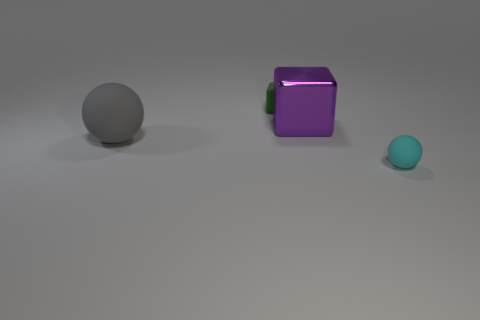Subtract 1 spheres. How many spheres are left? 1 Add 4 big metallic objects. How many big metallic objects are left? 5 Add 4 small purple matte cubes. How many small purple matte cubes exist? 4 Add 3 big red cylinders. How many objects exist? 7 Subtract all purple blocks. How many blocks are left? 1 Subtract 0 green cylinders. How many objects are left? 4 Subtract all blue cubes. Subtract all gray cylinders. How many cubes are left? 2 Subtract all red cubes. How many gray spheres are left? 1 Subtract all big cubes. Subtract all large gray things. How many objects are left? 2 